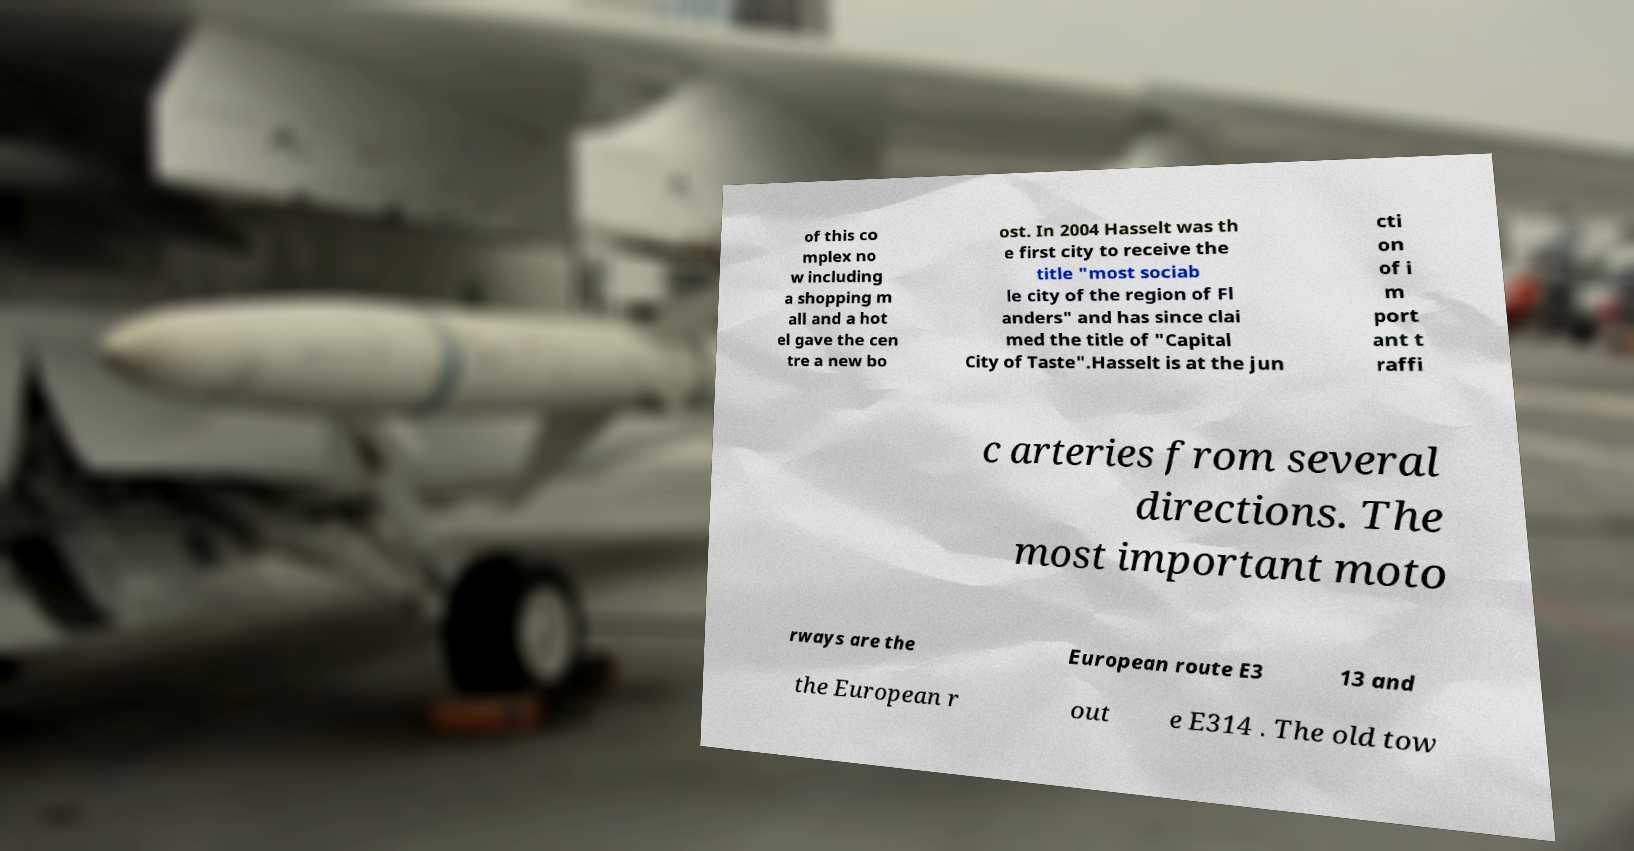There's text embedded in this image that I need extracted. Can you transcribe it verbatim? of this co mplex no w including a shopping m all and a hot el gave the cen tre a new bo ost. In 2004 Hasselt was th e first city to receive the title "most sociab le city of the region of Fl anders" and has since clai med the title of "Capital City of Taste".Hasselt is at the jun cti on of i m port ant t raffi c arteries from several directions. The most important moto rways are the European route E3 13 and the European r out e E314 . The old tow 